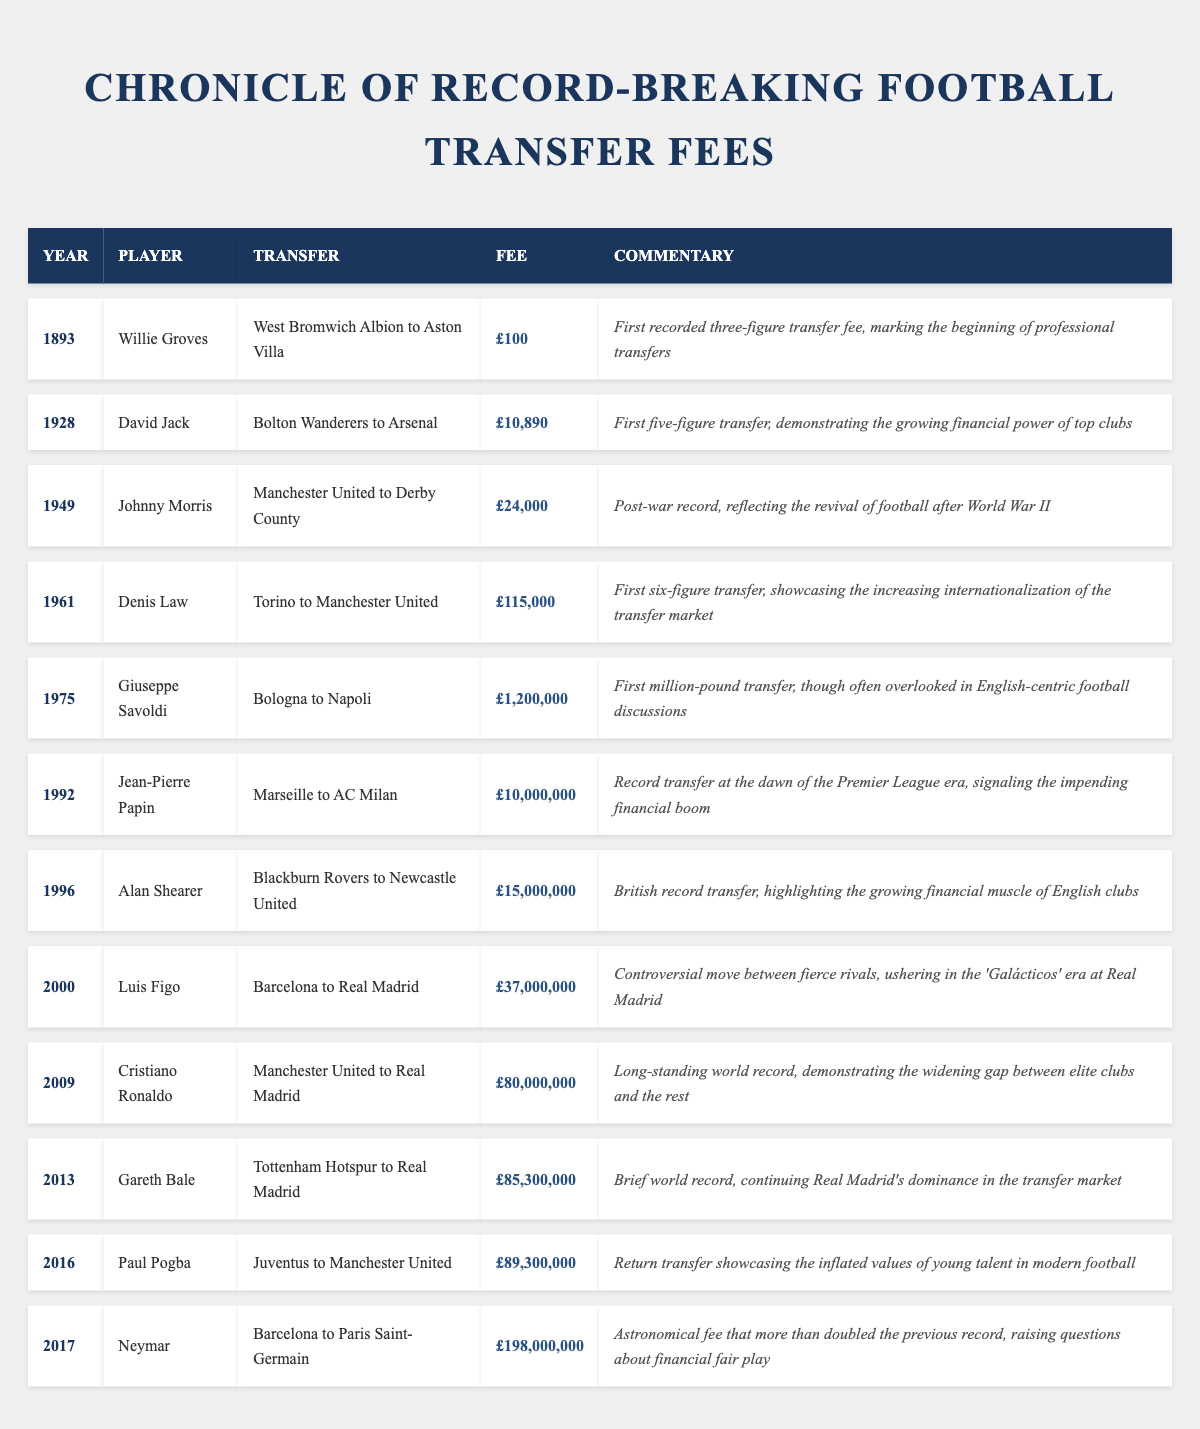What year did the first three-figure transfer fee occur? The first recorded three-figure transfer fee is attributed to Willie Groves, which took place in the year 1893.
Answer: 1893 Which player transferred for the highest fee, and how much was it? Neymar transferred for the highest fee of £198,000,000 in 2017 when he moved from Barcelona to Paris Saint-Germain.
Answer: Neymar, £198,000,000 Was the transfer fee for Paul Pogba higher or lower than that of Gareth Bale? Paul Pogba's transfer fee was £89,300,000 while Gareth Bale's fee was £85,300,000, making Pogba's fee higher.
Answer: Higher How many transfer records occurred in the 2000s? In the data, there are four transfers recorded in the 2000s: Luis Figo (2000), Cristiano Ronaldo (2009), Gareth Bale (2013), and Paul Pogba (2016), totaling four records.
Answer: Four What is the average transfer fee for the top three most expensive players? The top three fees are £198,000,000 (Neymar), £89,300,000 (Paul Pogba), and £85,300,000 (Gareth Bale). Summing these gives £198,000,000 + £89,300,000 + £85,300,000 = £372,600,000. Dividing by 3 (the number of players) gives an average of £124,200,000.
Answer: £124,200,000 In which year did the first million-pound transfer occur? The first million-pound transfer was for Giuseppe Savoldi, which took place in 1975 when he moved from Bologna to Napoli for £1,200,000.
Answer: 1975 Was Jean-Pierre Papin's transfer fee more than £10 million? Jean-Pierre Papin's transfer fee of £10,000,000 is exactly £10 million, which means it is not more than £10 million.
Answer: No Which player had the lowest recorded transfer fee, and what was it? Willie Groves had the lowest recorded transfer fee of £100 in 1893 when he transferred from West Bromwich Albion to Aston Villa.
Answer: Willie Groves, £100 